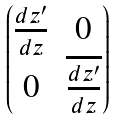Convert formula to latex. <formula><loc_0><loc_0><loc_500><loc_500>\begin{pmatrix} \frac { d z ^ { \prime } } { d z } & 0 \\ 0 & \overline { \frac { d z ^ { \prime } } { d z } } \end{pmatrix}</formula> 